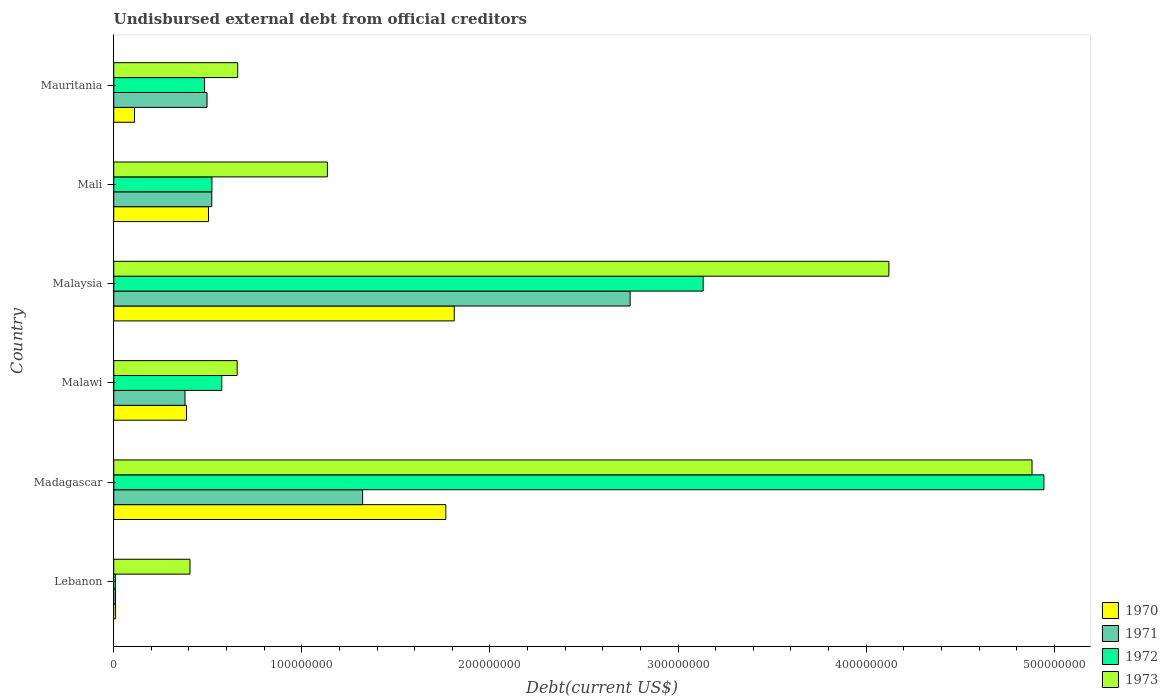How many different coloured bars are there?
Offer a terse response. 4. Are the number of bars per tick equal to the number of legend labels?
Offer a very short reply. Yes. Are the number of bars on each tick of the Y-axis equal?
Provide a succinct answer. Yes. How many bars are there on the 4th tick from the top?
Make the answer very short. 4. How many bars are there on the 3rd tick from the bottom?
Provide a short and direct response. 4. What is the label of the 1st group of bars from the top?
Provide a succinct answer. Mauritania. What is the total debt in 1973 in Mali?
Ensure brevity in your answer.  1.14e+08. Across all countries, what is the maximum total debt in 1973?
Provide a short and direct response. 4.88e+08. Across all countries, what is the minimum total debt in 1970?
Provide a succinct answer. 9.80e+05. In which country was the total debt in 1971 maximum?
Make the answer very short. Malaysia. In which country was the total debt in 1972 minimum?
Provide a short and direct response. Lebanon. What is the total total debt in 1970 in the graph?
Your answer should be very brief. 4.59e+08. What is the difference between the total debt in 1973 in Malawi and that in Mauritania?
Offer a very short reply. -3.01e+05. What is the difference between the total debt in 1971 in Mauritania and the total debt in 1972 in Madagascar?
Ensure brevity in your answer.  -4.45e+08. What is the average total debt in 1970 per country?
Keep it short and to the point. 7.64e+07. What is the difference between the total debt in 1972 and total debt in 1971 in Madagascar?
Offer a terse response. 3.62e+08. What is the ratio of the total debt in 1972 in Lebanon to that in Madagascar?
Ensure brevity in your answer.  0. What is the difference between the highest and the second highest total debt in 1971?
Make the answer very short. 1.42e+08. What is the difference between the highest and the lowest total debt in 1971?
Provide a short and direct response. 2.74e+08. In how many countries, is the total debt in 1970 greater than the average total debt in 1970 taken over all countries?
Keep it short and to the point. 2. Is the sum of the total debt in 1972 in Lebanon and Madagascar greater than the maximum total debt in 1973 across all countries?
Keep it short and to the point. Yes. Is it the case that in every country, the sum of the total debt in 1972 and total debt in 1973 is greater than the sum of total debt in 1970 and total debt in 1971?
Provide a succinct answer. No. What does the 2nd bar from the top in Mauritania represents?
Your answer should be very brief. 1972. What does the 3rd bar from the bottom in Lebanon represents?
Your answer should be very brief. 1972. Are all the bars in the graph horizontal?
Provide a succinct answer. Yes. How many countries are there in the graph?
Your answer should be very brief. 6. Are the values on the major ticks of X-axis written in scientific E-notation?
Offer a terse response. No. Does the graph contain any zero values?
Ensure brevity in your answer.  No. How many legend labels are there?
Make the answer very short. 4. How are the legend labels stacked?
Ensure brevity in your answer.  Vertical. What is the title of the graph?
Your answer should be very brief. Undisbursed external debt from official creditors. What is the label or title of the X-axis?
Your response must be concise. Debt(current US$). What is the Debt(current US$) in 1970 in Lebanon?
Provide a succinct answer. 9.80e+05. What is the Debt(current US$) in 1971 in Lebanon?
Your answer should be very brief. 9.32e+05. What is the Debt(current US$) of 1972 in Lebanon?
Make the answer very short. 9.32e+05. What is the Debt(current US$) of 1973 in Lebanon?
Offer a terse response. 4.05e+07. What is the Debt(current US$) of 1970 in Madagascar?
Keep it short and to the point. 1.76e+08. What is the Debt(current US$) of 1971 in Madagascar?
Your response must be concise. 1.32e+08. What is the Debt(current US$) of 1972 in Madagascar?
Your answer should be very brief. 4.94e+08. What is the Debt(current US$) in 1973 in Madagascar?
Ensure brevity in your answer.  4.88e+08. What is the Debt(current US$) in 1970 in Malawi?
Give a very brief answer. 3.87e+07. What is the Debt(current US$) of 1971 in Malawi?
Make the answer very short. 3.79e+07. What is the Debt(current US$) of 1972 in Malawi?
Keep it short and to the point. 5.74e+07. What is the Debt(current US$) in 1973 in Malawi?
Make the answer very short. 6.56e+07. What is the Debt(current US$) in 1970 in Malaysia?
Ensure brevity in your answer.  1.81e+08. What is the Debt(current US$) of 1971 in Malaysia?
Your answer should be compact. 2.74e+08. What is the Debt(current US$) of 1972 in Malaysia?
Provide a succinct answer. 3.13e+08. What is the Debt(current US$) of 1973 in Malaysia?
Your answer should be very brief. 4.12e+08. What is the Debt(current US$) in 1970 in Mali?
Your answer should be compact. 5.04e+07. What is the Debt(current US$) in 1971 in Mali?
Offer a terse response. 5.21e+07. What is the Debt(current US$) in 1972 in Mali?
Offer a terse response. 5.22e+07. What is the Debt(current US$) in 1973 in Mali?
Your answer should be very brief. 1.14e+08. What is the Debt(current US$) of 1970 in Mauritania?
Provide a succinct answer. 1.10e+07. What is the Debt(current US$) in 1971 in Mauritania?
Give a very brief answer. 4.96e+07. What is the Debt(current US$) in 1972 in Mauritania?
Make the answer very short. 4.83e+07. What is the Debt(current US$) of 1973 in Mauritania?
Provide a succinct answer. 6.59e+07. Across all countries, what is the maximum Debt(current US$) of 1970?
Offer a very short reply. 1.81e+08. Across all countries, what is the maximum Debt(current US$) in 1971?
Your response must be concise. 2.74e+08. Across all countries, what is the maximum Debt(current US$) in 1972?
Give a very brief answer. 4.94e+08. Across all countries, what is the maximum Debt(current US$) of 1973?
Keep it short and to the point. 4.88e+08. Across all countries, what is the minimum Debt(current US$) in 1970?
Offer a very short reply. 9.80e+05. Across all countries, what is the minimum Debt(current US$) of 1971?
Keep it short and to the point. 9.32e+05. Across all countries, what is the minimum Debt(current US$) in 1972?
Your response must be concise. 9.32e+05. Across all countries, what is the minimum Debt(current US$) in 1973?
Your response must be concise. 4.05e+07. What is the total Debt(current US$) in 1970 in the graph?
Keep it short and to the point. 4.59e+08. What is the total Debt(current US$) in 1971 in the graph?
Offer a terse response. 5.47e+08. What is the total Debt(current US$) in 1972 in the graph?
Make the answer very short. 9.67e+08. What is the total Debt(current US$) of 1973 in the graph?
Your answer should be very brief. 1.19e+09. What is the difference between the Debt(current US$) in 1970 in Lebanon and that in Madagascar?
Give a very brief answer. -1.76e+08. What is the difference between the Debt(current US$) in 1971 in Lebanon and that in Madagascar?
Give a very brief answer. -1.31e+08. What is the difference between the Debt(current US$) in 1972 in Lebanon and that in Madagascar?
Your response must be concise. -4.94e+08. What is the difference between the Debt(current US$) of 1973 in Lebanon and that in Madagascar?
Offer a terse response. -4.48e+08. What is the difference between the Debt(current US$) in 1970 in Lebanon and that in Malawi?
Offer a terse response. -3.77e+07. What is the difference between the Debt(current US$) in 1971 in Lebanon and that in Malawi?
Give a very brief answer. -3.70e+07. What is the difference between the Debt(current US$) of 1972 in Lebanon and that in Malawi?
Ensure brevity in your answer.  -5.65e+07. What is the difference between the Debt(current US$) of 1973 in Lebanon and that in Malawi?
Make the answer very short. -2.51e+07. What is the difference between the Debt(current US$) in 1970 in Lebanon and that in Malaysia?
Provide a succinct answer. -1.80e+08. What is the difference between the Debt(current US$) in 1971 in Lebanon and that in Malaysia?
Ensure brevity in your answer.  -2.74e+08. What is the difference between the Debt(current US$) of 1972 in Lebanon and that in Malaysia?
Make the answer very short. -3.12e+08. What is the difference between the Debt(current US$) in 1973 in Lebanon and that in Malaysia?
Give a very brief answer. -3.72e+08. What is the difference between the Debt(current US$) of 1970 in Lebanon and that in Mali?
Your answer should be compact. -4.94e+07. What is the difference between the Debt(current US$) of 1971 in Lebanon and that in Mali?
Provide a short and direct response. -5.12e+07. What is the difference between the Debt(current US$) in 1972 in Lebanon and that in Mali?
Give a very brief answer. -5.13e+07. What is the difference between the Debt(current US$) of 1973 in Lebanon and that in Mali?
Make the answer very short. -7.30e+07. What is the difference between the Debt(current US$) of 1970 in Lebanon and that in Mauritania?
Your answer should be very brief. -1.01e+07. What is the difference between the Debt(current US$) in 1971 in Lebanon and that in Mauritania?
Ensure brevity in your answer.  -4.87e+07. What is the difference between the Debt(current US$) in 1972 in Lebanon and that in Mauritania?
Make the answer very short. -4.74e+07. What is the difference between the Debt(current US$) of 1973 in Lebanon and that in Mauritania?
Your answer should be compact. -2.54e+07. What is the difference between the Debt(current US$) of 1970 in Madagascar and that in Malawi?
Offer a terse response. 1.38e+08. What is the difference between the Debt(current US$) of 1971 in Madagascar and that in Malawi?
Provide a succinct answer. 9.44e+07. What is the difference between the Debt(current US$) of 1972 in Madagascar and that in Malawi?
Give a very brief answer. 4.37e+08. What is the difference between the Debt(current US$) in 1973 in Madagascar and that in Malawi?
Provide a succinct answer. 4.23e+08. What is the difference between the Debt(current US$) in 1970 in Madagascar and that in Malaysia?
Offer a terse response. -4.51e+06. What is the difference between the Debt(current US$) of 1971 in Madagascar and that in Malaysia?
Offer a very short reply. -1.42e+08. What is the difference between the Debt(current US$) of 1972 in Madagascar and that in Malaysia?
Your response must be concise. 1.81e+08. What is the difference between the Debt(current US$) in 1973 in Madagascar and that in Malaysia?
Your response must be concise. 7.61e+07. What is the difference between the Debt(current US$) in 1970 in Madagascar and that in Mali?
Provide a short and direct response. 1.26e+08. What is the difference between the Debt(current US$) in 1971 in Madagascar and that in Mali?
Your response must be concise. 8.02e+07. What is the difference between the Debt(current US$) in 1972 in Madagascar and that in Mali?
Offer a terse response. 4.42e+08. What is the difference between the Debt(current US$) in 1973 in Madagascar and that in Mali?
Provide a short and direct response. 3.75e+08. What is the difference between the Debt(current US$) in 1970 in Madagascar and that in Mauritania?
Make the answer very short. 1.65e+08. What is the difference between the Debt(current US$) in 1971 in Madagascar and that in Mauritania?
Offer a terse response. 8.27e+07. What is the difference between the Debt(current US$) in 1972 in Madagascar and that in Mauritania?
Ensure brevity in your answer.  4.46e+08. What is the difference between the Debt(current US$) in 1973 in Madagascar and that in Mauritania?
Offer a very short reply. 4.22e+08. What is the difference between the Debt(current US$) of 1970 in Malawi and that in Malaysia?
Your response must be concise. -1.42e+08. What is the difference between the Debt(current US$) of 1971 in Malawi and that in Malaysia?
Provide a succinct answer. -2.37e+08. What is the difference between the Debt(current US$) in 1972 in Malawi and that in Malaysia?
Offer a terse response. -2.56e+08. What is the difference between the Debt(current US$) in 1973 in Malawi and that in Malaysia?
Your answer should be very brief. -3.46e+08. What is the difference between the Debt(current US$) in 1970 in Malawi and that in Mali?
Offer a terse response. -1.17e+07. What is the difference between the Debt(current US$) of 1971 in Malawi and that in Mali?
Make the answer very short. -1.42e+07. What is the difference between the Debt(current US$) of 1972 in Malawi and that in Mali?
Give a very brief answer. 5.24e+06. What is the difference between the Debt(current US$) in 1973 in Malawi and that in Mali?
Your answer should be very brief. -4.80e+07. What is the difference between the Debt(current US$) of 1970 in Malawi and that in Mauritania?
Keep it short and to the point. 2.76e+07. What is the difference between the Debt(current US$) of 1971 in Malawi and that in Mauritania?
Your answer should be very brief. -1.17e+07. What is the difference between the Debt(current US$) of 1972 in Malawi and that in Mauritania?
Offer a very short reply. 9.13e+06. What is the difference between the Debt(current US$) of 1973 in Malawi and that in Mauritania?
Give a very brief answer. -3.01e+05. What is the difference between the Debt(current US$) in 1970 in Malaysia and that in Mali?
Keep it short and to the point. 1.31e+08. What is the difference between the Debt(current US$) of 1971 in Malaysia and that in Mali?
Keep it short and to the point. 2.22e+08. What is the difference between the Debt(current US$) in 1972 in Malaysia and that in Mali?
Ensure brevity in your answer.  2.61e+08. What is the difference between the Debt(current US$) of 1973 in Malaysia and that in Mali?
Keep it short and to the point. 2.98e+08. What is the difference between the Debt(current US$) in 1970 in Malaysia and that in Mauritania?
Make the answer very short. 1.70e+08. What is the difference between the Debt(current US$) of 1971 in Malaysia and that in Mauritania?
Your answer should be compact. 2.25e+08. What is the difference between the Debt(current US$) in 1972 in Malaysia and that in Mauritania?
Your answer should be compact. 2.65e+08. What is the difference between the Debt(current US$) of 1973 in Malaysia and that in Mauritania?
Provide a succinct answer. 3.46e+08. What is the difference between the Debt(current US$) in 1970 in Mali and that in Mauritania?
Make the answer very short. 3.93e+07. What is the difference between the Debt(current US$) of 1971 in Mali and that in Mauritania?
Your response must be concise. 2.51e+06. What is the difference between the Debt(current US$) in 1972 in Mali and that in Mauritania?
Make the answer very short. 3.90e+06. What is the difference between the Debt(current US$) of 1973 in Mali and that in Mauritania?
Offer a terse response. 4.77e+07. What is the difference between the Debt(current US$) of 1970 in Lebanon and the Debt(current US$) of 1971 in Madagascar?
Your response must be concise. -1.31e+08. What is the difference between the Debt(current US$) of 1970 in Lebanon and the Debt(current US$) of 1972 in Madagascar?
Offer a terse response. -4.93e+08. What is the difference between the Debt(current US$) in 1970 in Lebanon and the Debt(current US$) in 1973 in Madagascar?
Make the answer very short. -4.87e+08. What is the difference between the Debt(current US$) of 1971 in Lebanon and the Debt(current US$) of 1972 in Madagascar?
Give a very brief answer. -4.94e+08. What is the difference between the Debt(current US$) in 1971 in Lebanon and the Debt(current US$) in 1973 in Madagascar?
Your response must be concise. -4.87e+08. What is the difference between the Debt(current US$) of 1972 in Lebanon and the Debt(current US$) of 1973 in Madagascar?
Ensure brevity in your answer.  -4.87e+08. What is the difference between the Debt(current US$) in 1970 in Lebanon and the Debt(current US$) in 1971 in Malawi?
Your answer should be compact. -3.69e+07. What is the difference between the Debt(current US$) in 1970 in Lebanon and the Debt(current US$) in 1972 in Malawi?
Ensure brevity in your answer.  -5.64e+07. What is the difference between the Debt(current US$) in 1970 in Lebanon and the Debt(current US$) in 1973 in Malawi?
Your response must be concise. -6.46e+07. What is the difference between the Debt(current US$) of 1971 in Lebanon and the Debt(current US$) of 1972 in Malawi?
Offer a terse response. -5.65e+07. What is the difference between the Debt(current US$) in 1971 in Lebanon and the Debt(current US$) in 1973 in Malawi?
Ensure brevity in your answer.  -6.47e+07. What is the difference between the Debt(current US$) in 1972 in Lebanon and the Debt(current US$) in 1973 in Malawi?
Offer a very short reply. -6.47e+07. What is the difference between the Debt(current US$) in 1970 in Lebanon and the Debt(current US$) in 1971 in Malaysia?
Your answer should be compact. -2.74e+08. What is the difference between the Debt(current US$) of 1970 in Lebanon and the Debt(current US$) of 1972 in Malaysia?
Provide a succinct answer. -3.12e+08. What is the difference between the Debt(current US$) in 1970 in Lebanon and the Debt(current US$) in 1973 in Malaysia?
Make the answer very short. -4.11e+08. What is the difference between the Debt(current US$) of 1971 in Lebanon and the Debt(current US$) of 1972 in Malaysia?
Your response must be concise. -3.12e+08. What is the difference between the Debt(current US$) in 1971 in Lebanon and the Debt(current US$) in 1973 in Malaysia?
Make the answer very short. -4.11e+08. What is the difference between the Debt(current US$) of 1972 in Lebanon and the Debt(current US$) of 1973 in Malaysia?
Your answer should be very brief. -4.11e+08. What is the difference between the Debt(current US$) in 1970 in Lebanon and the Debt(current US$) in 1971 in Mali?
Offer a terse response. -5.11e+07. What is the difference between the Debt(current US$) in 1970 in Lebanon and the Debt(current US$) in 1972 in Mali?
Offer a terse response. -5.12e+07. What is the difference between the Debt(current US$) in 1970 in Lebanon and the Debt(current US$) in 1973 in Mali?
Provide a succinct answer. -1.13e+08. What is the difference between the Debt(current US$) in 1971 in Lebanon and the Debt(current US$) in 1972 in Mali?
Your answer should be compact. -5.13e+07. What is the difference between the Debt(current US$) of 1971 in Lebanon and the Debt(current US$) of 1973 in Mali?
Keep it short and to the point. -1.13e+08. What is the difference between the Debt(current US$) in 1972 in Lebanon and the Debt(current US$) in 1973 in Mali?
Make the answer very short. -1.13e+08. What is the difference between the Debt(current US$) of 1970 in Lebanon and the Debt(current US$) of 1971 in Mauritania?
Ensure brevity in your answer.  -4.86e+07. What is the difference between the Debt(current US$) of 1970 in Lebanon and the Debt(current US$) of 1972 in Mauritania?
Your response must be concise. -4.73e+07. What is the difference between the Debt(current US$) in 1970 in Lebanon and the Debt(current US$) in 1973 in Mauritania?
Your response must be concise. -6.49e+07. What is the difference between the Debt(current US$) in 1971 in Lebanon and the Debt(current US$) in 1972 in Mauritania?
Provide a succinct answer. -4.74e+07. What is the difference between the Debt(current US$) of 1971 in Lebanon and the Debt(current US$) of 1973 in Mauritania?
Offer a terse response. -6.50e+07. What is the difference between the Debt(current US$) in 1972 in Lebanon and the Debt(current US$) in 1973 in Mauritania?
Provide a succinct answer. -6.50e+07. What is the difference between the Debt(current US$) of 1970 in Madagascar and the Debt(current US$) of 1971 in Malawi?
Provide a succinct answer. 1.39e+08. What is the difference between the Debt(current US$) in 1970 in Madagascar and the Debt(current US$) in 1972 in Malawi?
Your response must be concise. 1.19e+08. What is the difference between the Debt(current US$) in 1970 in Madagascar and the Debt(current US$) in 1973 in Malawi?
Offer a very short reply. 1.11e+08. What is the difference between the Debt(current US$) of 1971 in Madagascar and the Debt(current US$) of 1972 in Malawi?
Give a very brief answer. 7.49e+07. What is the difference between the Debt(current US$) in 1971 in Madagascar and the Debt(current US$) in 1973 in Malawi?
Offer a very short reply. 6.67e+07. What is the difference between the Debt(current US$) of 1972 in Madagascar and the Debt(current US$) of 1973 in Malawi?
Provide a short and direct response. 4.29e+08. What is the difference between the Debt(current US$) of 1970 in Madagascar and the Debt(current US$) of 1971 in Malaysia?
Provide a succinct answer. -9.80e+07. What is the difference between the Debt(current US$) of 1970 in Madagascar and the Debt(current US$) of 1972 in Malaysia?
Provide a short and direct response. -1.37e+08. What is the difference between the Debt(current US$) of 1970 in Madagascar and the Debt(current US$) of 1973 in Malaysia?
Your response must be concise. -2.36e+08. What is the difference between the Debt(current US$) in 1971 in Madagascar and the Debt(current US$) in 1972 in Malaysia?
Your answer should be very brief. -1.81e+08. What is the difference between the Debt(current US$) of 1971 in Madagascar and the Debt(current US$) of 1973 in Malaysia?
Give a very brief answer. -2.80e+08. What is the difference between the Debt(current US$) of 1972 in Madagascar and the Debt(current US$) of 1973 in Malaysia?
Offer a terse response. 8.24e+07. What is the difference between the Debt(current US$) in 1970 in Madagascar and the Debt(current US$) in 1971 in Mali?
Provide a short and direct response. 1.24e+08. What is the difference between the Debt(current US$) in 1970 in Madagascar and the Debt(current US$) in 1972 in Mali?
Your answer should be very brief. 1.24e+08. What is the difference between the Debt(current US$) of 1970 in Madagascar and the Debt(current US$) of 1973 in Mali?
Your answer should be very brief. 6.29e+07. What is the difference between the Debt(current US$) in 1971 in Madagascar and the Debt(current US$) in 1972 in Mali?
Give a very brief answer. 8.01e+07. What is the difference between the Debt(current US$) in 1971 in Madagascar and the Debt(current US$) in 1973 in Mali?
Give a very brief answer. 1.87e+07. What is the difference between the Debt(current US$) of 1972 in Madagascar and the Debt(current US$) of 1973 in Mali?
Your answer should be compact. 3.81e+08. What is the difference between the Debt(current US$) in 1970 in Madagascar and the Debt(current US$) in 1971 in Mauritania?
Keep it short and to the point. 1.27e+08. What is the difference between the Debt(current US$) of 1970 in Madagascar and the Debt(current US$) of 1972 in Mauritania?
Your answer should be compact. 1.28e+08. What is the difference between the Debt(current US$) of 1970 in Madagascar and the Debt(current US$) of 1973 in Mauritania?
Keep it short and to the point. 1.11e+08. What is the difference between the Debt(current US$) of 1971 in Madagascar and the Debt(current US$) of 1972 in Mauritania?
Make the answer very short. 8.40e+07. What is the difference between the Debt(current US$) in 1971 in Madagascar and the Debt(current US$) in 1973 in Mauritania?
Provide a succinct answer. 6.64e+07. What is the difference between the Debt(current US$) in 1972 in Madagascar and the Debt(current US$) in 1973 in Mauritania?
Provide a succinct answer. 4.29e+08. What is the difference between the Debt(current US$) of 1970 in Malawi and the Debt(current US$) of 1971 in Malaysia?
Ensure brevity in your answer.  -2.36e+08. What is the difference between the Debt(current US$) of 1970 in Malawi and the Debt(current US$) of 1972 in Malaysia?
Ensure brevity in your answer.  -2.75e+08. What is the difference between the Debt(current US$) of 1970 in Malawi and the Debt(current US$) of 1973 in Malaysia?
Make the answer very short. -3.73e+08. What is the difference between the Debt(current US$) in 1971 in Malawi and the Debt(current US$) in 1972 in Malaysia?
Provide a succinct answer. -2.75e+08. What is the difference between the Debt(current US$) of 1971 in Malawi and the Debt(current US$) of 1973 in Malaysia?
Your answer should be compact. -3.74e+08. What is the difference between the Debt(current US$) of 1972 in Malawi and the Debt(current US$) of 1973 in Malaysia?
Provide a short and direct response. -3.55e+08. What is the difference between the Debt(current US$) of 1970 in Malawi and the Debt(current US$) of 1971 in Mali?
Offer a terse response. -1.34e+07. What is the difference between the Debt(current US$) in 1970 in Malawi and the Debt(current US$) in 1972 in Mali?
Offer a terse response. -1.35e+07. What is the difference between the Debt(current US$) in 1970 in Malawi and the Debt(current US$) in 1973 in Mali?
Offer a terse response. -7.49e+07. What is the difference between the Debt(current US$) of 1971 in Malawi and the Debt(current US$) of 1972 in Mali?
Offer a terse response. -1.43e+07. What is the difference between the Debt(current US$) in 1971 in Malawi and the Debt(current US$) in 1973 in Mali?
Your answer should be very brief. -7.57e+07. What is the difference between the Debt(current US$) in 1972 in Malawi and the Debt(current US$) in 1973 in Mali?
Your response must be concise. -5.61e+07. What is the difference between the Debt(current US$) of 1970 in Malawi and the Debt(current US$) of 1971 in Mauritania?
Provide a short and direct response. -1.09e+07. What is the difference between the Debt(current US$) in 1970 in Malawi and the Debt(current US$) in 1972 in Mauritania?
Your answer should be compact. -9.63e+06. What is the difference between the Debt(current US$) in 1970 in Malawi and the Debt(current US$) in 1973 in Mauritania?
Your answer should be compact. -2.72e+07. What is the difference between the Debt(current US$) in 1971 in Malawi and the Debt(current US$) in 1972 in Mauritania?
Make the answer very short. -1.04e+07. What is the difference between the Debt(current US$) in 1971 in Malawi and the Debt(current US$) in 1973 in Mauritania?
Give a very brief answer. -2.80e+07. What is the difference between the Debt(current US$) in 1972 in Malawi and the Debt(current US$) in 1973 in Mauritania?
Provide a short and direct response. -8.47e+06. What is the difference between the Debt(current US$) of 1970 in Malaysia and the Debt(current US$) of 1971 in Mali?
Ensure brevity in your answer.  1.29e+08. What is the difference between the Debt(current US$) in 1970 in Malaysia and the Debt(current US$) in 1972 in Mali?
Your response must be concise. 1.29e+08. What is the difference between the Debt(current US$) of 1970 in Malaysia and the Debt(current US$) of 1973 in Mali?
Your response must be concise. 6.74e+07. What is the difference between the Debt(current US$) of 1971 in Malaysia and the Debt(current US$) of 1972 in Mali?
Offer a very short reply. 2.22e+08. What is the difference between the Debt(current US$) in 1971 in Malaysia and the Debt(current US$) in 1973 in Mali?
Your response must be concise. 1.61e+08. What is the difference between the Debt(current US$) of 1972 in Malaysia and the Debt(current US$) of 1973 in Mali?
Make the answer very short. 2.00e+08. What is the difference between the Debt(current US$) in 1970 in Malaysia and the Debt(current US$) in 1971 in Mauritania?
Provide a succinct answer. 1.31e+08. What is the difference between the Debt(current US$) in 1970 in Malaysia and the Debt(current US$) in 1972 in Mauritania?
Provide a succinct answer. 1.33e+08. What is the difference between the Debt(current US$) of 1970 in Malaysia and the Debt(current US$) of 1973 in Mauritania?
Make the answer very short. 1.15e+08. What is the difference between the Debt(current US$) of 1971 in Malaysia and the Debt(current US$) of 1972 in Mauritania?
Give a very brief answer. 2.26e+08. What is the difference between the Debt(current US$) of 1971 in Malaysia and the Debt(current US$) of 1973 in Mauritania?
Ensure brevity in your answer.  2.09e+08. What is the difference between the Debt(current US$) in 1972 in Malaysia and the Debt(current US$) in 1973 in Mauritania?
Offer a terse response. 2.47e+08. What is the difference between the Debt(current US$) of 1970 in Mali and the Debt(current US$) of 1971 in Mauritania?
Provide a succinct answer. 7.72e+05. What is the difference between the Debt(current US$) of 1970 in Mali and the Debt(current US$) of 1972 in Mauritania?
Your answer should be very brief. 2.07e+06. What is the difference between the Debt(current US$) in 1970 in Mali and the Debt(current US$) in 1973 in Mauritania?
Keep it short and to the point. -1.55e+07. What is the difference between the Debt(current US$) of 1971 in Mali and the Debt(current US$) of 1972 in Mauritania?
Keep it short and to the point. 3.81e+06. What is the difference between the Debt(current US$) of 1971 in Mali and the Debt(current US$) of 1973 in Mauritania?
Your answer should be very brief. -1.38e+07. What is the difference between the Debt(current US$) of 1972 in Mali and the Debt(current US$) of 1973 in Mauritania?
Your response must be concise. -1.37e+07. What is the average Debt(current US$) of 1970 per country?
Ensure brevity in your answer.  7.64e+07. What is the average Debt(current US$) in 1971 per country?
Provide a short and direct response. 9.12e+07. What is the average Debt(current US$) of 1972 per country?
Your answer should be compact. 1.61e+08. What is the average Debt(current US$) of 1973 per country?
Your answer should be very brief. 1.98e+08. What is the difference between the Debt(current US$) in 1970 and Debt(current US$) in 1971 in Lebanon?
Offer a very short reply. 4.80e+04. What is the difference between the Debt(current US$) in 1970 and Debt(current US$) in 1972 in Lebanon?
Your response must be concise. 4.80e+04. What is the difference between the Debt(current US$) of 1970 and Debt(current US$) of 1973 in Lebanon?
Offer a terse response. -3.96e+07. What is the difference between the Debt(current US$) of 1971 and Debt(current US$) of 1973 in Lebanon?
Provide a succinct answer. -3.96e+07. What is the difference between the Debt(current US$) in 1972 and Debt(current US$) in 1973 in Lebanon?
Provide a short and direct response. -3.96e+07. What is the difference between the Debt(current US$) of 1970 and Debt(current US$) of 1971 in Madagascar?
Make the answer very short. 4.42e+07. What is the difference between the Debt(current US$) in 1970 and Debt(current US$) in 1972 in Madagascar?
Make the answer very short. -3.18e+08. What is the difference between the Debt(current US$) in 1970 and Debt(current US$) in 1973 in Madagascar?
Offer a very short reply. -3.12e+08. What is the difference between the Debt(current US$) in 1971 and Debt(current US$) in 1972 in Madagascar?
Make the answer very short. -3.62e+08. What is the difference between the Debt(current US$) in 1971 and Debt(current US$) in 1973 in Madagascar?
Keep it short and to the point. -3.56e+08. What is the difference between the Debt(current US$) of 1972 and Debt(current US$) of 1973 in Madagascar?
Make the answer very short. 6.33e+06. What is the difference between the Debt(current US$) in 1970 and Debt(current US$) in 1971 in Malawi?
Your answer should be compact. 7.85e+05. What is the difference between the Debt(current US$) in 1970 and Debt(current US$) in 1972 in Malawi?
Offer a very short reply. -1.88e+07. What is the difference between the Debt(current US$) in 1970 and Debt(current US$) in 1973 in Malawi?
Offer a terse response. -2.69e+07. What is the difference between the Debt(current US$) of 1971 and Debt(current US$) of 1972 in Malawi?
Give a very brief answer. -1.95e+07. What is the difference between the Debt(current US$) in 1971 and Debt(current US$) in 1973 in Malawi?
Provide a succinct answer. -2.77e+07. What is the difference between the Debt(current US$) in 1972 and Debt(current US$) in 1973 in Malawi?
Ensure brevity in your answer.  -8.17e+06. What is the difference between the Debt(current US$) of 1970 and Debt(current US$) of 1971 in Malaysia?
Make the answer very short. -9.35e+07. What is the difference between the Debt(current US$) of 1970 and Debt(current US$) of 1972 in Malaysia?
Give a very brief answer. -1.32e+08. What is the difference between the Debt(current US$) of 1970 and Debt(current US$) of 1973 in Malaysia?
Ensure brevity in your answer.  -2.31e+08. What is the difference between the Debt(current US$) of 1971 and Debt(current US$) of 1972 in Malaysia?
Your response must be concise. -3.88e+07. What is the difference between the Debt(current US$) of 1971 and Debt(current US$) of 1973 in Malaysia?
Offer a very short reply. -1.38e+08. What is the difference between the Debt(current US$) of 1972 and Debt(current US$) of 1973 in Malaysia?
Give a very brief answer. -9.87e+07. What is the difference between the Debt(current US$) of 1970 and Debt(current US$) of 1971 in Mali?
Make the answer very short. -1.74e+06. What is the difference between the Debt(current US$) of 1970 and Debt(current US$) of 1972 in Mali?
Your answer should be compact. -1.82e+06. What is the difference between the Debt(current US$) in 1970 and Debt(current US$) in 1973 in Mali?
Offer a terse response. -6.32e+07. What is the difference between the Debt(current US$) of 1971 and Debt(current US$) of 1972 in Mali?
Provide a short and direct response. -8.30e+04. What is the difference between the Debt(current US$) in 1971 and Debt(current US$) in 1973 in Mali?
Your answer should be compact. -6.15e+07. What is the difference between the Debt(current US$) in 1972 and Debt(current US$) in 1973 in Mali?
Your answer should be very brief. -6.14e+07. What is the difference between the Debt(current US$) in 1970 and Debt(current US$) in 1971 in Mauritania?
Provide a short and direct response. -3.85e+07. What is the difference between the Debt(current US$) of 1970 and Debt(current US$) of 1972 in Mauritania?
Make the answer very short. -3.72e+07. What is the difference between the Debt(current US$) in 1970 and Debt(current US$) in 1973 in Mauritania?
Provide a short and direct response. -5.49e+07. What is the difference between the Debt(current US$) in 1971 and Debt(current US$) in 1972 in Mauritania?
Provide a short and direct response. 1.30e+06. What is the difference between the Debt(current US$) in 1971 and Debt(current US$) in 1973 in Mauritania?
Provide a short and direct response. -1.63e+07. What is the difference between the Debt(current US$) of 1972 and Debt(current US$) of 1973 in Mauritania?
Keep it short and to the point. -1.76e+07. What is the ratio of the Debt(current US$) in 1970 in Lebanon to that in Madagascar?
Your response must be concise. 0.01. What is the ratio of the Debt(current US$) in 1971 in Lebanon to that in Madagascar?
Provide a short and direct response. 0.01. What is the ratio of the Debt(current US$) of 1972 in Lebanon to that in Madagascar?
Offer a very short reply. 0. What is the ratio of the Debt(current US$) of 1973 in Lebanon to that in Madagascar?
Your answer should be compact. 0.08. What is the ratio of the Debt(current US$) of 1970 in Lebanon to that in Malawi?
Your answer should be compact. 0.03. What is the ratio of the Debt(current US$) in 1971 in Lebanon to that in Malawi?
Your answer should be compact. 0.02. What is the ratio of the Debt(current US$) of 1972 in Lebanon to that in Malawi?
Make the answer very short. 0.02. What is the ratio of the Debt(current US$) of 1973 in Lebanon to that in Malawi?
Offer a very short reply. 0.62. What is the ratio of the Debt(current US$) in 1970 in Lebanon to that in Malaysia?
Make the answer very short. 0.01. What is the ratio of the Debt(current US$) in 1971 in Lebanon to that in Malaysia?
Provide a succinct answer. 0. What is the ratio of the Debt(current US$) in 1972 in Lebanon to that in Malaysia?
Make the answer very short. 0. What is the ratio of the Debt(current US$) of 1973 in Lebanon to that in Malaysia?
Keep it short and to the point. 0.1. What is the ratio of the Debt(current US$) of 1970 in Lebanon to that in Mali?
Offer a terse response. 0.02. What is the ratio of the Debt(current US$) of 1971 in Lebanon to that in Mali?
Offer a very short reply. 0.02. What is the ratio of the Debt(current US$) of 1972 in Lebanon to that in Mali?
Your answer should be compact. 0.02. What is the ratio of the Debt(current US$) of 1973 in Lebanon to that in Mali?
Keep it short and to the point. 0.36. What is the ratio of the Debt(current US$) of 1970 in Lebanon to that in Mauritania?
Make the answer very short. 0.09. What is the ratio of the Debt(current US$) in 1971 in Lebanon to that in Mauritania?
Give a very brief answer. 0.02. What is the ratio of the Debt(current US$) of 1972 in Lebanon to that in Mauritania?
Offer a very short reply. 0.02. What is the ratio of the Debt(current US$) of 1973 in Lebanon to that in Mauritania?
Your response must be concise. 0.62. What is the ratio of the Debt(current US$) of 1970 in Madagascar to that in Malawi?
Give a very brief answer. 4.56. What is the ratio of the Debt(current US$) of 1971 in Madagascar to that in Malawi?
Your answer should be compact. 3.49. What is the ratio of the Debt(current US$) of 1972 in Madagascar to that in Malawi?
Provide a short and direct response. 8.61. What is the ratio of the Debt(current US$) in 1973 in Madagascar to that in Malawi?
Provide a succinct answer. 7.44. What is the ratio of the Debt(current US$) in 1970 in Madagascar to that in Malaysia?
Offer a terse response. 0.98. What is the ratio of the Debt(current US$) of 1971 in Madagascar to that in Malaysia?
Make the answer very short. 0.48. What is the ratio of the Debt(current US$) of 1972 in Madagascar to that in Malaysia?
Provide a short and direct response. 1.58. What is the ratio of the Debt(current US$) of 1973 in Madagascar to that in Malaysia?
Offer a terse response. 1.18. What is the ratio of the Debt(current US$) in 1970 in Madagascar to that in Mali?
Provide a short and direct response. 3.5. What is the ratio of the Debt(current US$) in 1971 in Madagascar to that in Mali?
Provide a succinct answer. 2.54. What is the ratio of the Debt(current US$) in 1972 in Madagascar to that in Mali?
Offer a very short reply. 9.47. What is the ratio of the Debt(current US$) in 1973 in Madagascar to that in Mali?
Provide a short and direct response. 4.3. What is the ratio of the Debt(current US$) of 1970 in Madagascar to that in Mauritania?
Give a very brief answer. 15.98. What is the ratio of the Debt(current US$) of 1971 in Madagascar to that in Mauritania?
Offer a very short reply. 2.67. What is the ratio of the Debt(current US$) in 1972 in Madagascar to that in Mauritania?
Provide a short and direct response. 10.24. What is the ratio of the Debt(current US$) of 1973 in Madagascar to that in Mauritania?
Make the answer very short. 7.41. What is the ratio of the Debt(current US$) of 1970 in Malawi to that in Malaysia?
Offer a very short reply. 0.21. What is the ratio of the Debt(current US$) of 1971 in Malawi to that in Malaysia?
Offer a very short reply. 0.14. What is the ratio of the Debt(current US$) in 1972 in Malawi to that in Malaysia?
Provide a short and direct response. 0.18. What is the ratio of the Debt(current US$) of 1973 in Malawi to that in Malaysia?
Your answer should be very brief. 0.16. What is the ratio of the Debt(current US$) of 1970 in Malawi to that in Mali?
Keep it short and to the point. 0.77. What is the ratio of the Debt(current US$) in 1971 in Malawi to that in Mali?
Make the answer very short. 0.73. What is the ratio of the Debt(current US$) in 1972 in Malawi to that in Mali?
Keep it short and to the point. 1.1. What is the ratio of the Debt(current US$) in 1973 in Malawi to that in Mali?
Offer a very short reply. 0.58. What is the ratio of the Debt(current US$) in 1970 in Malawi to that in Mauritania?
Offer a very short reply. 3.5. What is the ratio of the Debt(current US$) of 1971 in Malawi to that in Mauritania?
Ensure brevity in your answer.  0.76. What is the ratio of the Debt(current US$) of 1972 in Malawi to that in Mauritania?
Offer a very short reply. 1.19. What is the ratio of the Debt(current US$) in 1970 in Malaysia to that in Mali?
Ensure brevity in your answer.  3.59. What is the ratio of the Debt(current US$) of 1971 in Malaysia to that in Mali?
Provide a short and direct response. 5.27. What is the ratio of the Debt(current US$) in 1972 in Malaysia to that in Mali?
Give a very brief answer. 6. What is the ratio of the Debt(current US$) in 1973 in Malaysia to that in Mali?
Your answer should be very brief. 3.63. What is the ratio of the Debt(current US$) in 1970 in Malaysia to that in Mauritania?
Provide a short and direct response. 16.39. What is the ratio of the Debt(current US$) of 1971 in Malaysia to that in Mauritania?
Your answer should be compact. 5.54. What is the ratio of the Debt(current US$) in 1972 in Malaysia to that in Mauritania?
Ensure brevity in your answer.  6.49. What is the ratio of the Debt(current US$) in 1973 in Malaysia to that in Mauritania?
Give a very brief answer. 6.25. What is the ratio of the Debt(current US$) of 1970 in Mali to that in Mauritania?
Keep it short and to the point. 4.56. What is the ratio of the Debt(current US$) of 1971 in Mali to that in Mauritania?
Your answer should be very brief. 1.05. What is the ratio of the Debt(current US$) in 1972 in Mali to that in Mauritania?
Offer a very short reply. 1.08. What is the ratio of the Debt(current US$) of 1973 in Mali to that in Mauritania?
Offer a very short reply. 1.72. What is the difference between the highest and the second highest Debt(current US$) of 1970?
Ensure brevity in your answer.  4.51e+06. What is the difference between the highest and the second highest Debt(current US$) in 1971?
Offer a terse response. 1.42e+08. What is the difference between the highest and the second highest Debt(current US$) of 1972?
Your answer should be very brief. 1.81e+08. What is the difference between the highest and the second highest Debt(current US$) in 1973?
Keep it short and to the point. 7.61e+07. What is the difference between the highest and the lowest Debt(current US$) in 1970?
Keep it short and to the point. 1.80e+08. What is the difference between the highest and the lowest Debt(current US$) in 1971?
Make the answer very short. 2.74e+08. What is the difference between the highest and the lowest Debt(current US$) of 1972?
Your answer should be very brief. 4.94e+08. What is the difference between the highest and the lowest Debt(current US$) in 1973?
Provide a succinct answer. 4.48e+08. 